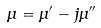<formula> <loc_0><loc_0><loc_500><loc_500>\mu = \mu ^ { \prime } - j \mu ^ { \prime \prime }</formula> 